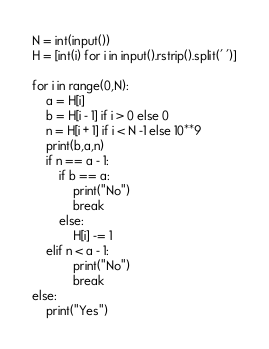<code> <loc_0><loc_0><loc_500><loc_500><_Python_>N = int(input())
H = [int(i) for i in input().rstrip().split(' ')]

for i in range(0,N):
    a = H[i]
    b = H[i - 1] if i > 0 else 0
    n = H[i + 1] if i < N -1 else 10**9
    print(b,a,n)
    if n == a - 1:
        if b == a:
            print("No")
            break
        else:
            H[i] -= 1
    elif n < a - 1:
            print("No")
            break
else:
    print("Yes")</code> 